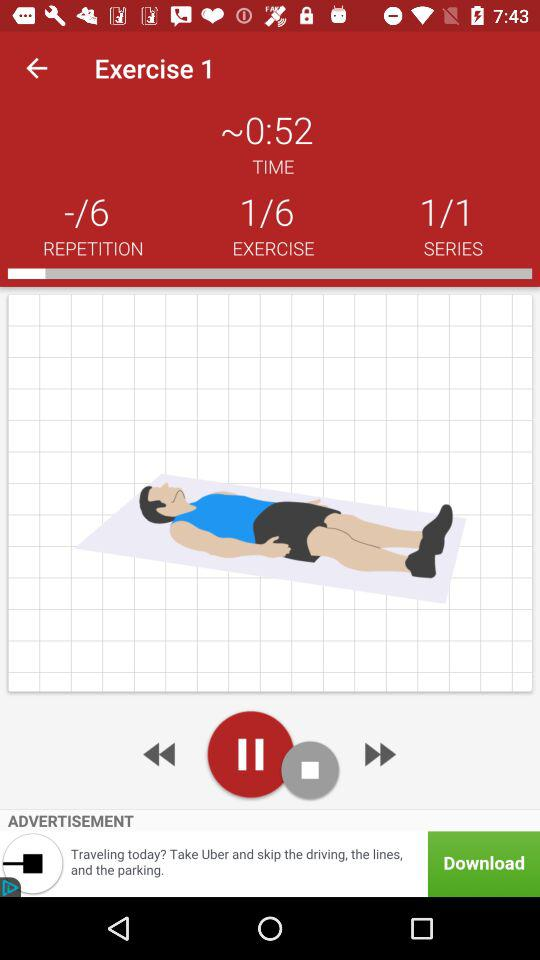How many seconds are there? There are 52 seconds. 